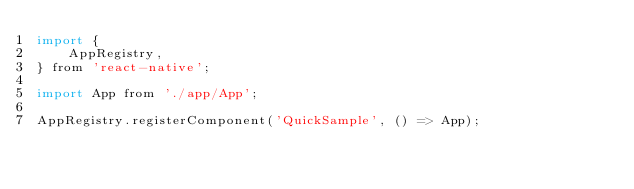Convert code to text. <code><loc_0><loc_0><loc_500><loc_500><_JavaScript_>import {
    AppRegistry,
} from 'react-native';

import App from './app/App';

AppRegistry.registerComponent('QuickSample', () => App);
</code> 